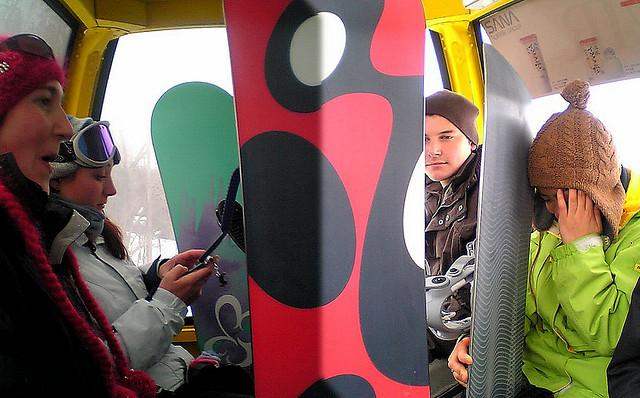What winter sport is this group participating in? snowboarding 